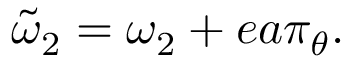<formula> <loc_0><loc_0><loc_500><loc_500>\tilde { \omega } _ { 2 } = \omega _ { 2 } + e a \pi _ { \theta } .</formula> 